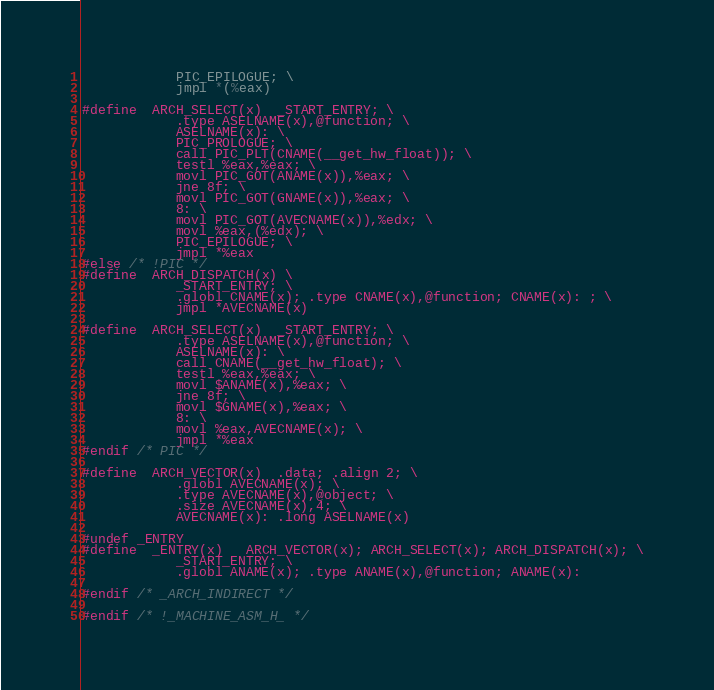Convert code to text. <code><loc_0><loc_0><loc_500><loc_500><_C_>			PIC_EPILOGUE; \
			jmpl *(%eax)

#define	ARCH_SELECT(x)	_START_ENTRY; \
			.type ASELNAME(x),@function; \
			ASELNAME(x): \
			PIC_PROLOGUE; \
			call PIC_PLT(CNAME(__get_hw_float)); \
			testl %eax,%eax; \
			movl PIC_GOT(ANAME(x)),%eax; \
			jne 8f; \
			movl PIC_GOT(GNAME(x)),%eax; \
			8: \
			movl PIC_GOT(AVECNAME(x)),%edx; \
			movl %eax,(%edx); \
			PIC_EPILOGUE; \
			jmpl *%eax
#else /* !PIC */
#define	ARCH_DISPATCH(x) \
			_START_ENTRY; \
			.globl CNAME(x); .type CNAME(x),@function; CNAME(x): ; \
			jmpl *AVECNAME(x)

#define	ARCH_SELECT(x)	_START_ENTRY; \
			.type ASELNAME(x),@function; \
			ASELNAME(x): \
			call CNAME(__get_hw_float); \
			testl %eax,%eax; \
			movl $ANAME(x),%eax; \
			jne 8f; \
			movl $GNAME(x),%eax; \
			8: \
			movl %eax,AVECNAME(x); \
			jmpl *%eax
#endif /* PIC */

#define	ARCH_VECTOR(x)	.data; .align 2; \
			.globl AVECNAME(x); \
			.type AVECNAME(x),@object; \
			.size AVECNAME(x),4; \
			AVECNAME(x): .long ASELNAME(x)

#undef _ENTRY
#define	_ENTRY(x)	ARCH_VECTOR(x); ARCH_SELECT(x); ARCH_DISPATCH(x); \
			_START_ENTRY; \
			.globl ANAME(x); .type ANAME(x),@function; ANAME(x):

#endif /* _ARCH_INDIRECT */

#endif /* !_MACHINE_ASM_H_ */
</code> 